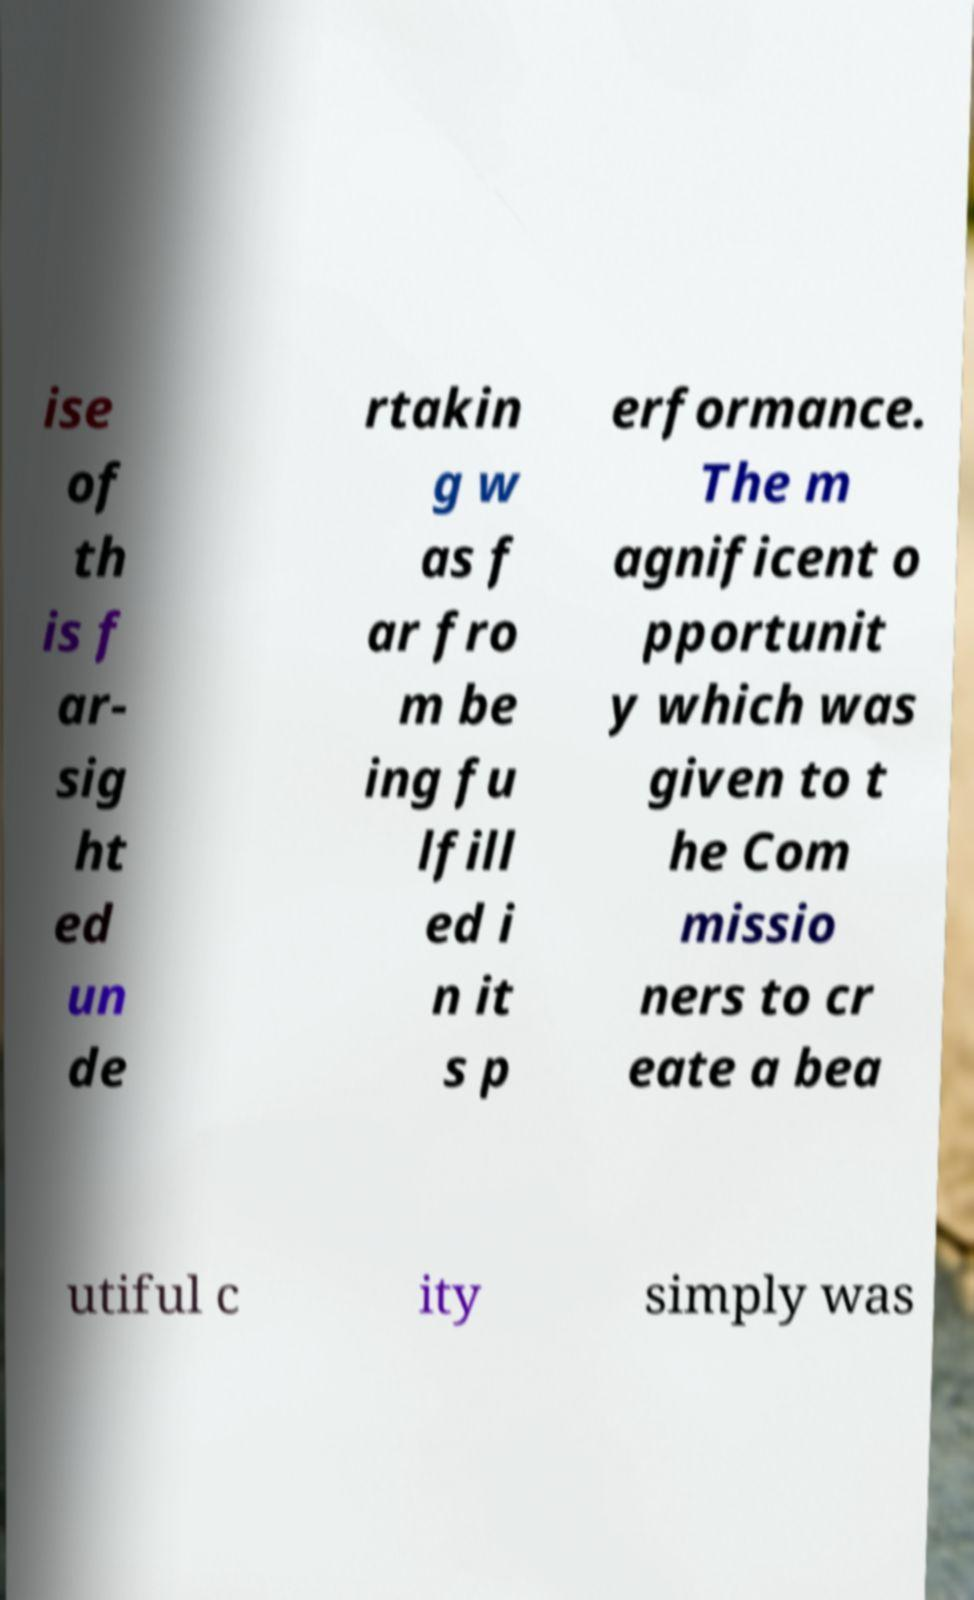Can you read and provide the text displayed in the image?This photo seems to have some interesting text. Can you extract and type it out for me? ise of th is f ar- sig ht ed un de rtakin g w as f ar fro m be ing fu lfill ed i n it s p erformance. The m agnificent o pportunit y which was given to t he Com missio ners to cr eate a bea utiful c ity simply was 